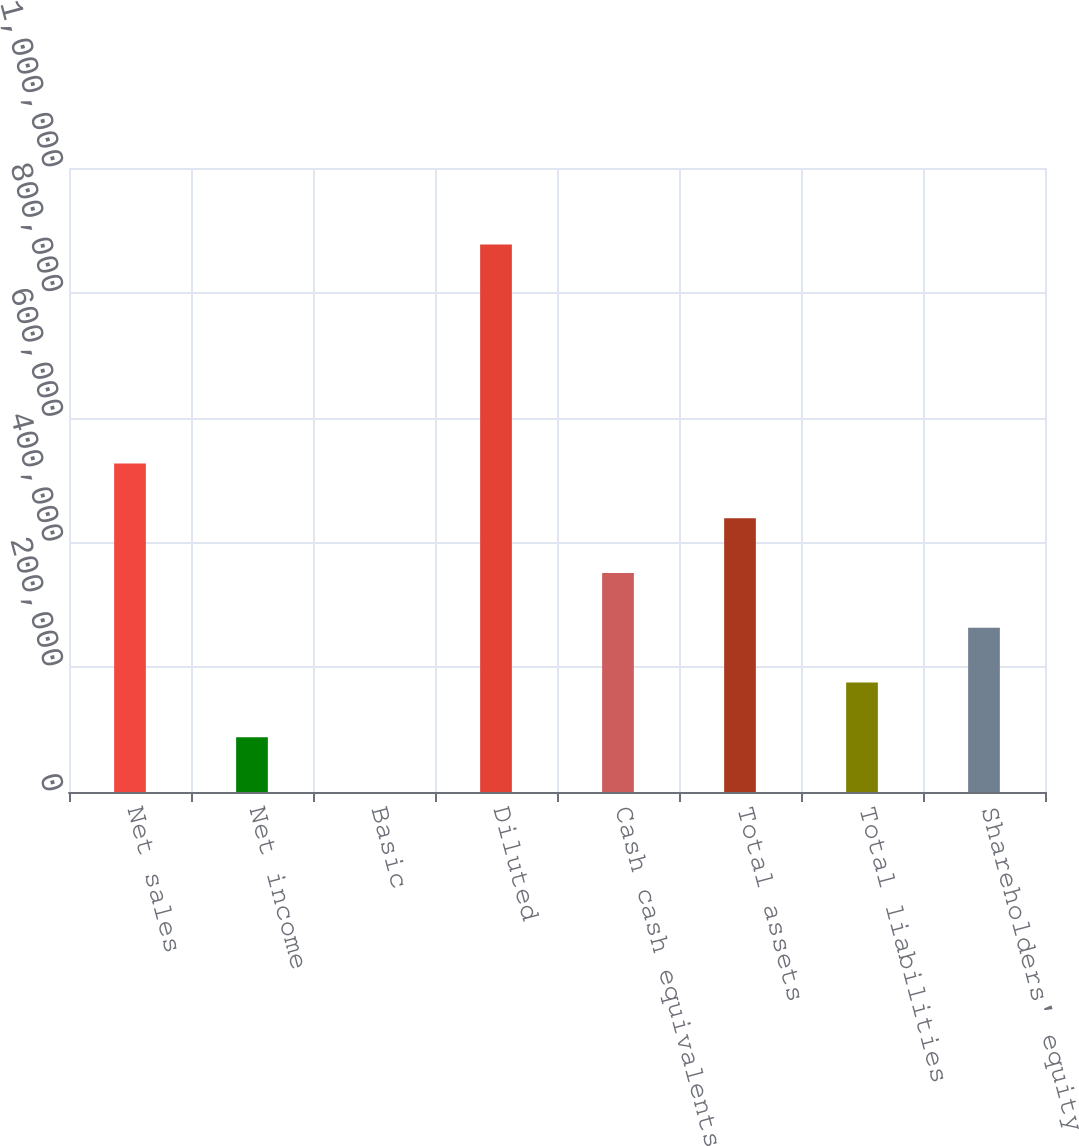Convert chart to OTSL. <chart><loc_0><loc_0><loc_500><loc_500><bar_chart><fcel>Net sales<fcel>Net income<fcel>Basic<fcel>Diluted<fcel>Cash cash equivalents and<fcel>Total assets<fcel>Total liabilities<fcel>Shareholders' equity<nl><fcel>526517<fcel>87754.7<fcel>2.36<fcel>877526<fcel>351012<fcel>438764<fcel>175507<fcel>263259<nl></chart> 